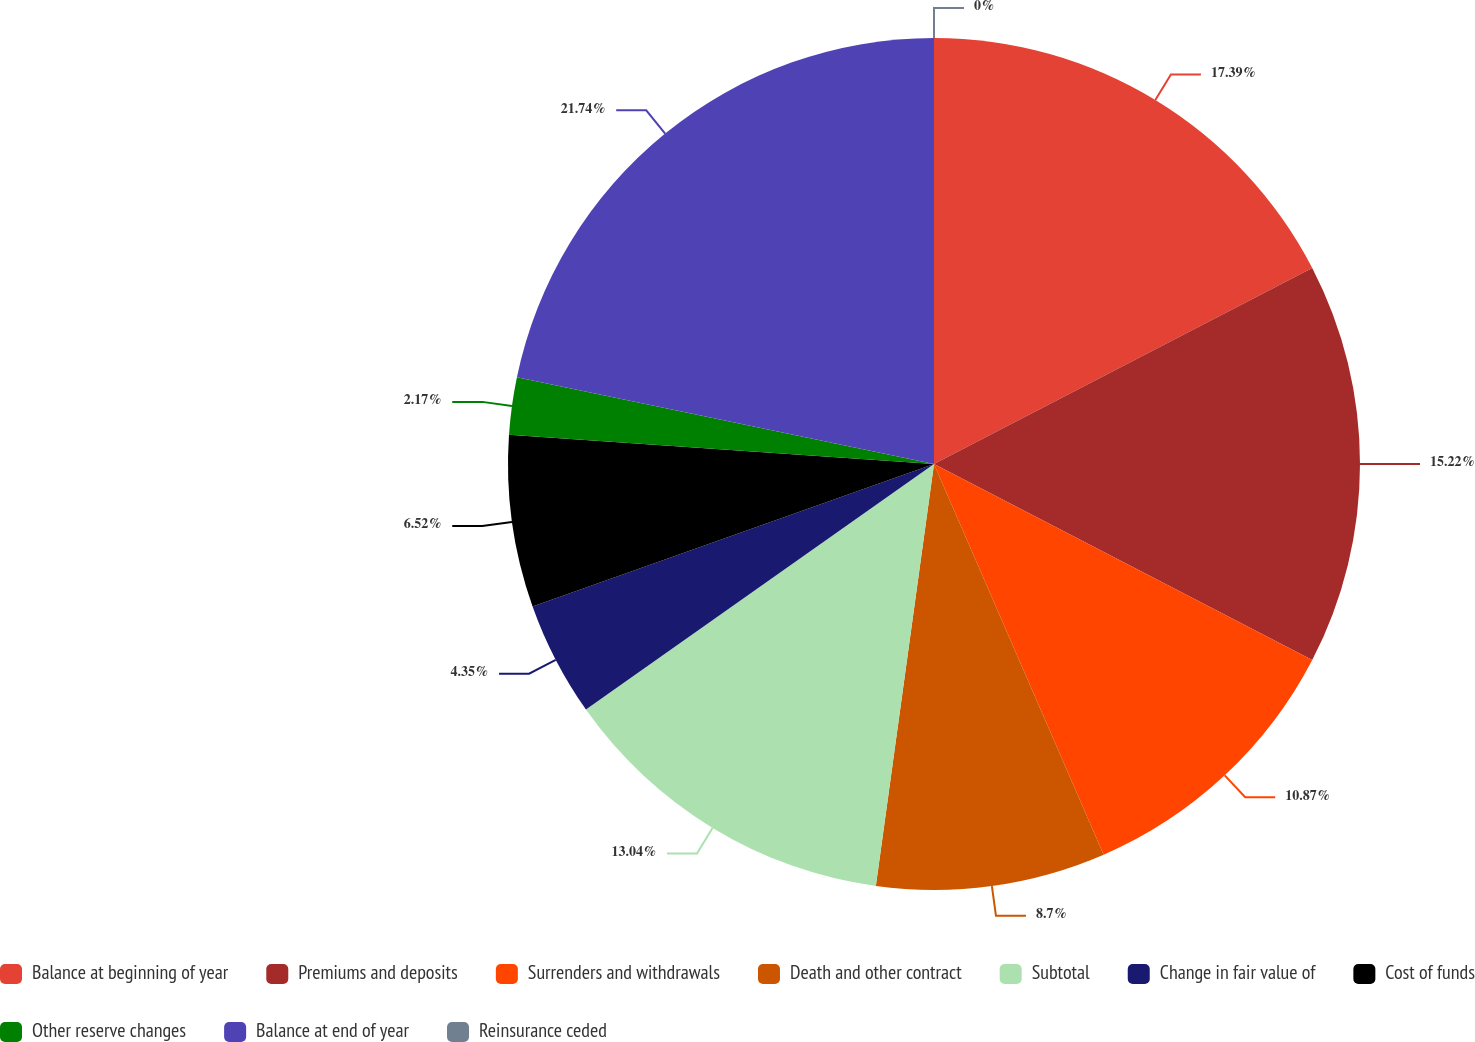Convert chart. <chart><loc_0><loc_0><loc_500><loc_500><pie_chart><fcel>Balance at beginning of year<fcel>Premiums and deposits<fcel>Surrenders and withdrawals<fcel>Death and other contract<fcel>Subtotal<fcel>Change in fair value of<fcel>Cost of funds<fcel>Other reserve changes<fcel>Balance at end of year<fcel>Reinsurance ceded<nl><fcel>17.39%<fcel>15.22%<fcel>10.87%<fcel>8.7%<fcel>13.04%<fcel>4.35%<fcel>6.52%<fcel>2.17%<fcel>21.74%<fcel>0.0%<nl></chart> 